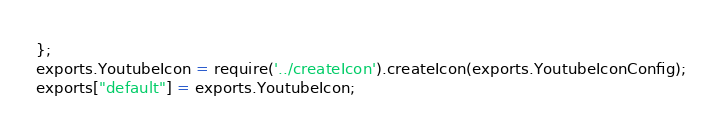Convert code to text. <code><loc_0><loc_0><loc_500><loc_500><_JavaScript_>};
exports.YoutubeIcon = require('../createIcon').createIcon(exports.YoutubeIconConfig);
exports["default"] = exports.YoutubeIcon;</code> 